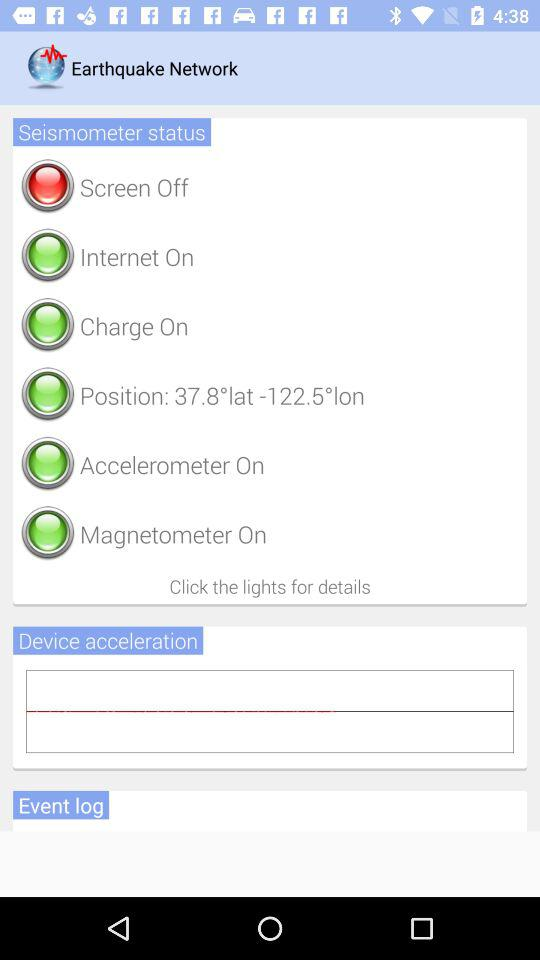What is the position of the seismometer? The position is 37.8°-1225°lon. 